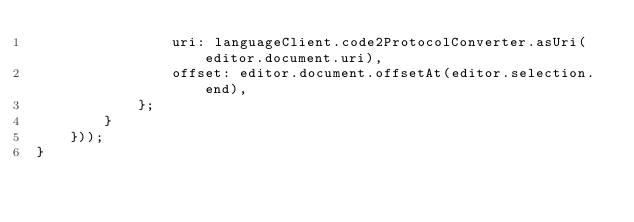<code> <loc_0><loc_0><loc_500><loc_500><_TypeScript_>                uri: languageClient.code2ProtocolConverter.asUri(editor.document.uri),
                offset: editor.document.offsetAt(editor.selection.end),
            };
        }
    }));
}
</code> 